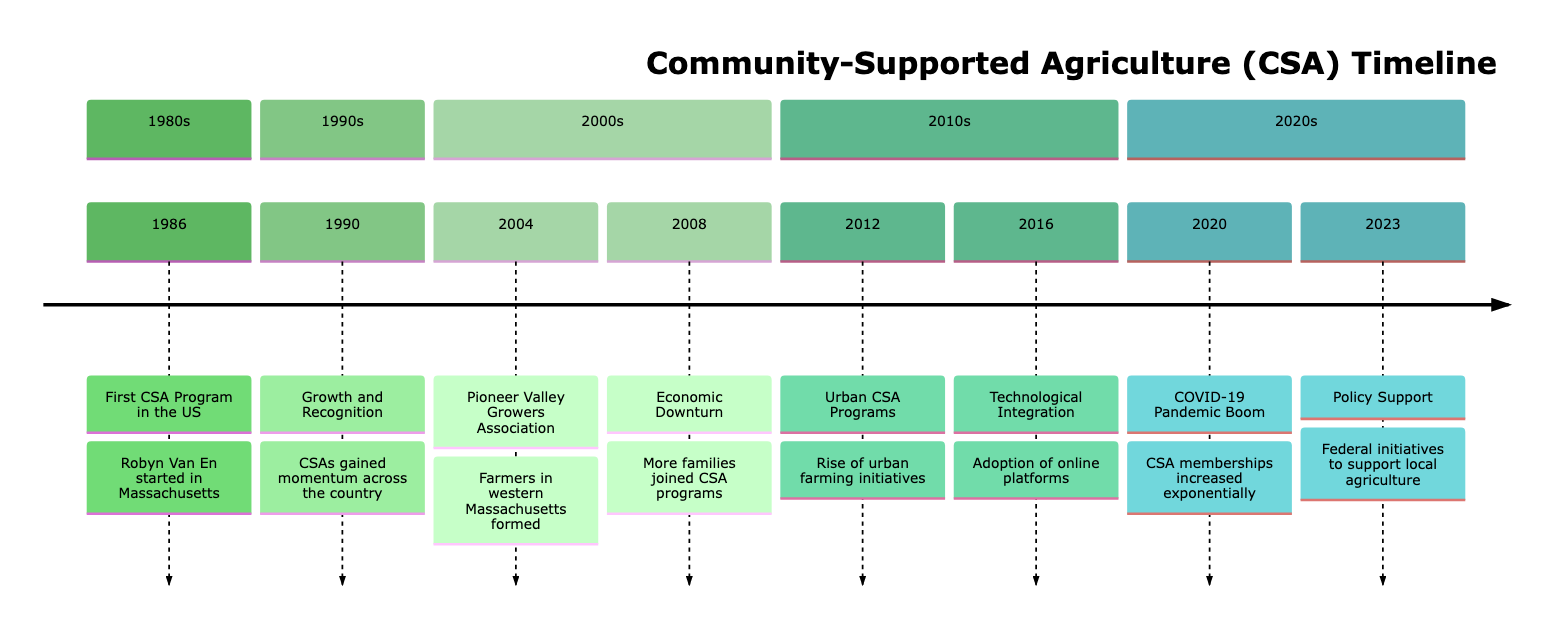What year did the first CSA program start in the US? The diagram indicates that the first CSA program in the US began in 1986. This event is highlighted in the first section of the timeline.
Answer: 1986 How many significant events are there in the timeline? By counting all the events presented in the timeline, we find there are eight major milestones listed across the years. This can be seen by simply counting each listed event.
Answer: 8 What was a major factor for the increase in CSA memberships in 2020? The timeline specifically describes the COVID-19 pandemic as the major factor that led to an exponential increase in CSA memberships, highlighting the community's shift toward local food sources.
Answer: COVID-19 Pandemic What organization was formed in 2004 in Massachusetts? The diagram states that the Pioneer Valley Growers Association was established in 2004, as noted in its corresponding event description.
Answer: Pioneer Valley Growers Association Which year saw the introduction of federal initiatives to support local agriculture? According to the timeline, the year when federal initiatives to support local agriculture were introduced is 2023, as indicated in the last section of the diagram.
Answer: 2023 What trend in urban farming began in 2012? The timeline mentions the rise of urban CSA programs as a significant trend that began in 2012, noting its emergence in major cities.
Answer: Urban CSA Programs What technological advancement occurred in 2016? As per the timeline, the adoption of online platforms for managing CSA subscriptions is specified as the major technological advancement in 2016.
Answer: Technological Integration Which decade saw the first CSA program in the US? The timeline clarifies that the first CSA program started in the 1980s, particularly in the year 1986 as the very first event listed.
Answer: 1980s 